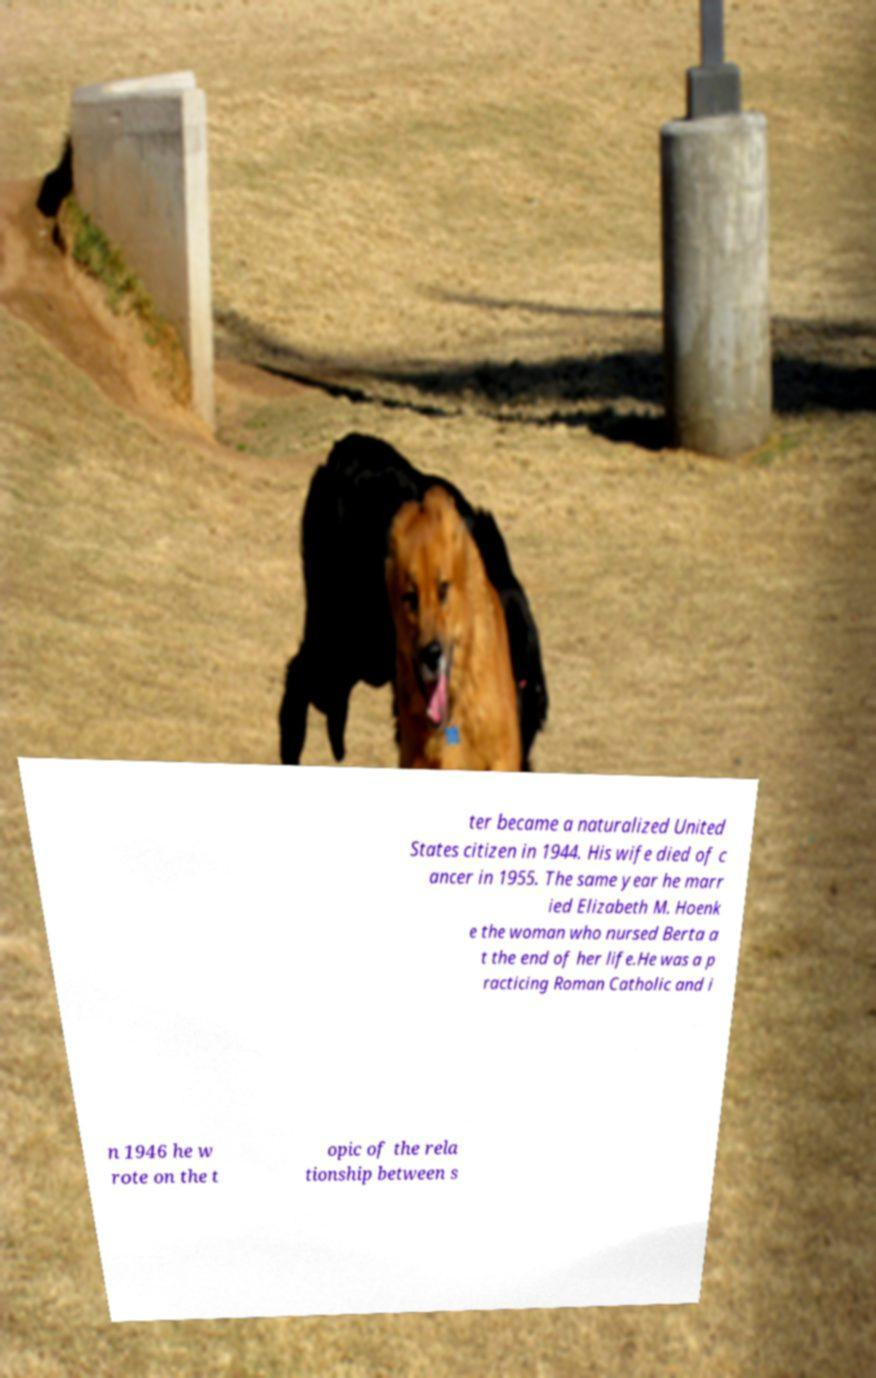For documentation purposes, I need the text within this image transcribed. Could you provide that? ter became a naturalized United States citizen in 1944. His wife died of c ancer in 1955. The same year he marr ied Elizabeth M. Hoenk e the woman who nursed Berta a t the end of her life.He was a p racticing Roman Catholic and i n 1946 he w rote on the t opic of the rela tionship between s 